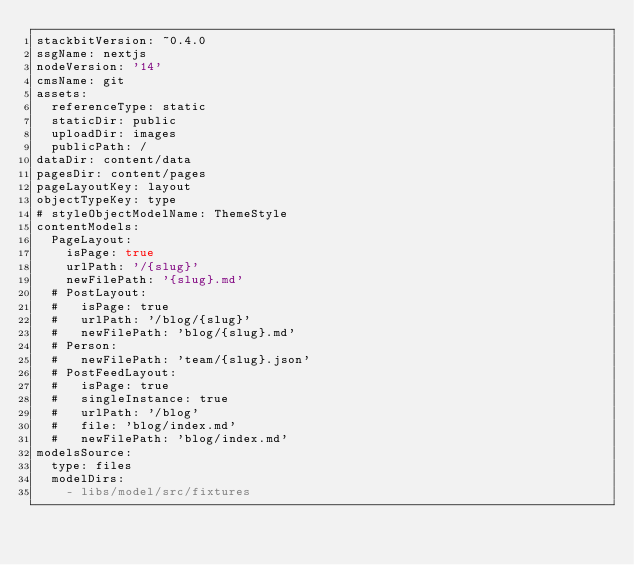<code> <loc_0><loc_0><loc_500><loc_500><_YAML_>stackbitVersion: ~0.4.0
ssgName: nextjs
nodeVersion: '14'
cmsName: git
assets:
  referenceType: static
  staticDir: public
  uploadDir: images
  publicPath: /
dataDir: content/data
pagesDir: content/pages
pageLayoutKey: layout
objectTypeKey: type
# styleObjectModelName: ThemeStyle
contentModels:
  PageLayout:
    isPage: true
    urlPath: '/{slug}'
    newFilePath: '{slug}.md'
  # PostLayout:
  #   isPage: true
  #   urlPath: '/blog/{slug}'
  #   newFilePath: 'blog/{slug}.md'
  # Person:
  #   newFilePath: 'team/{slug}.json'
  # PostFeedLayout:
  #   isPage: true
  #   singleInstance: true
  #   urlPath: '/blog'
  #   file: 'blog/index.md'
  #   newFilePath: 'blog/index.md'
modelsSource:
  type: files
  modelDirs:
    - libs/model/src/fixtures
</code> 